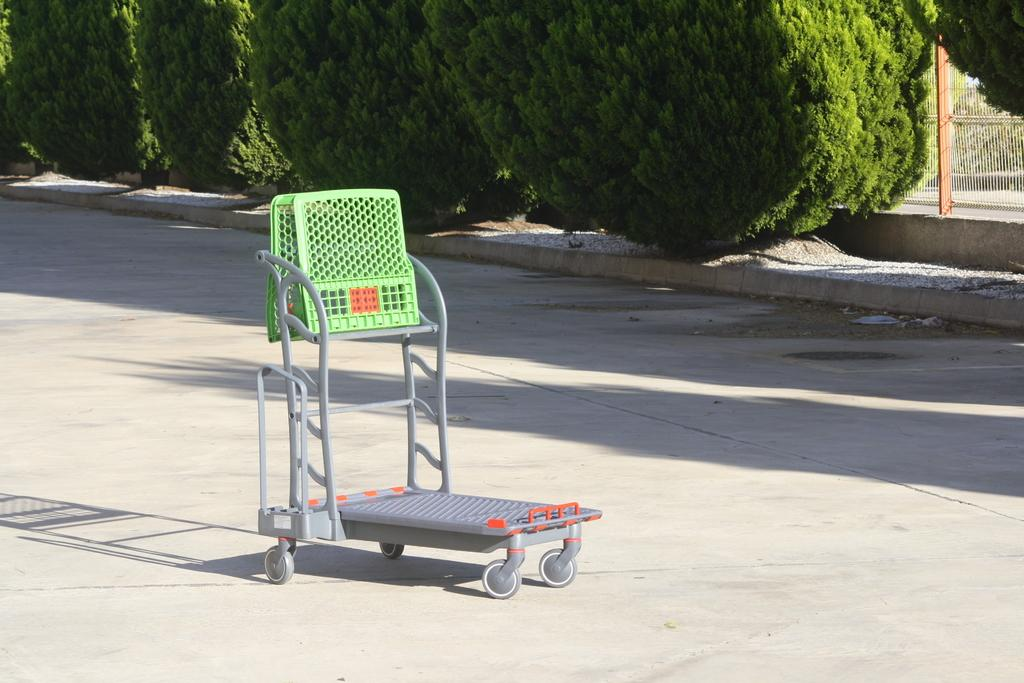What type of metal object can be seen in the image? There is a metal object in the image, but the specific type is not mentioned. What natural elements are present in the image? There are trees in the image. What man-made structures can be seen in the image? There is a fence and a pole in the image. What type of pathway is visible in the image? There is a road in the image. What type of alarm is attached to the metal object in the image? There is no alarm present in the image. What story is being told by the trees in the image? The trees in the image are not telling a story; they are simply natural elements in the scene. 